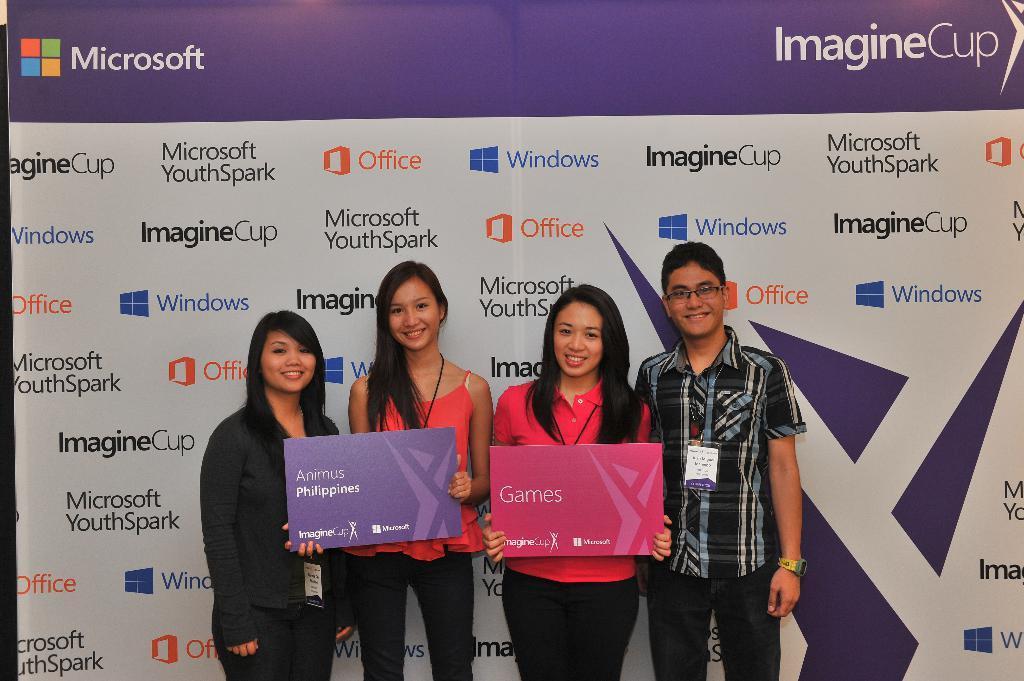Can you describe this image briefly? In this image, we can see four people are standing. They are watching and smiling. Here two women are holding boards. Background there is a banner. In the banner, we can see some text and logos. 